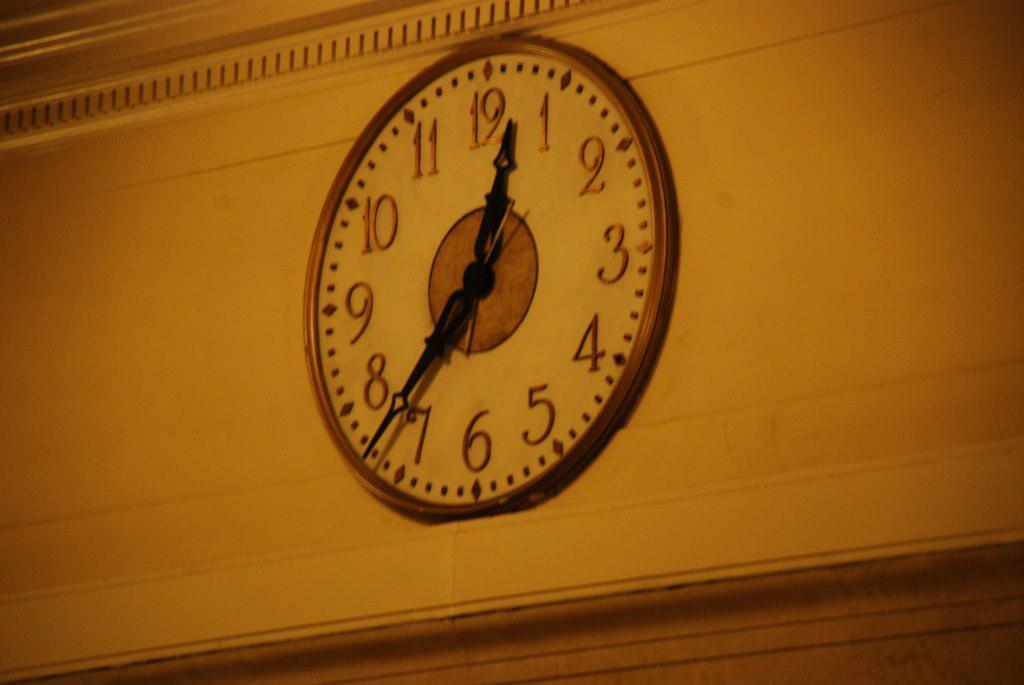<image>
Render a clear and concise summary of the photo. A clock alone on the wall that reads 12:37 